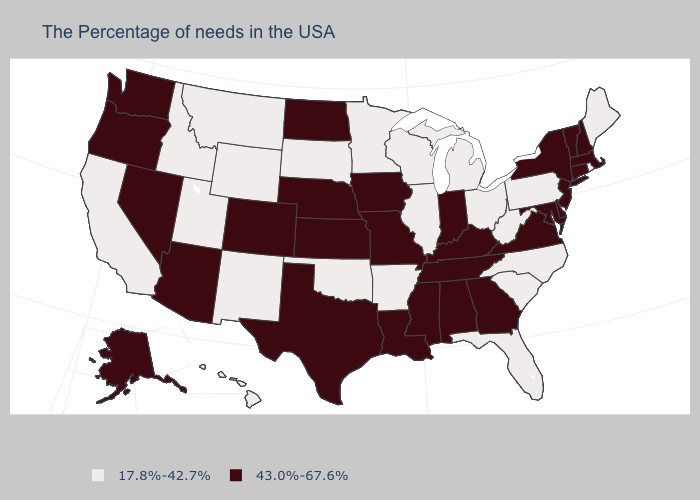What is the value of Vermont?
Give a very brief answer. 43.0%-67.6%. Does the map have missing data?
Give a very brief answer. No. How many symbols are there in the legend?
Quick response, please. 2. Among the states that border Louisiana , does Texas have the highest value?
Answer briefly. Yes. Which states have the lowest value in the USA?
Concise answer only. Maine, Rhode Island, Pennsylvania, North Carolina, South Carolina, West Virginia, Ohio, Florida, Michigan, Wisconsin, Illinois, Arkansas, Minnesota, Oklahoma, South Dakota, Wyoming, New Mexico, Utah, Montana, Idaho, California, Hawaii. How many symbols are there in the legend?
Write a very short answer. 2. What is the value of West Virginia?
Give a very brief answer. 17.8%-42.7%. Does Virginia have the same value as Massachusetts?
Concise answer only. Yes. Name the states that have a value in the range 43.0%-67.6%?
Answer briefly. Massachusetts, New Hampshire, Vermont, Connecticut, New York, New Jersey, Delaware, Maryland, Virginia, Georgia, Kentucky, Indiana, Alabama, Tennessee, Mississippi, Louisiana, Missouri, Iowa, Kansas, Nebraska, Texas, North Dakota, Colorado, Arizona, Nevada, Washington, Oregon, Alaska. Which states hav the highest value in the South?
Keep it brief. Delaware, Maryland, Virginia, Georgia, Kentucky, Alabama, Tennessee, Mississippi, Louisiana, Texas. Which states have the lowest value in the USA?
Write a very short answer. Maine, Rhode Island, Pennsylvania, North Carolina, South Carolina, West Virginia, Ohio, Florida, Michigan, Wisconsin, Illinois, Arkansas, Minnesota, Oklahoma, South Dakota, Wyoming, New Mexico, Utah, Montana, Idaho, California, Hawaii. What is the value of Oregon?
Write a very short answer. 43.0%-67.6%. Does the map have missing data?
Give a very brief answer. No. Among the states that border Alabama , which have the highest value?
Answer briefly. Georgia, Tennessee, Mississippi. Among the states that border Illinois , which have the lowest value?
Be succinct. Wisconsin. 